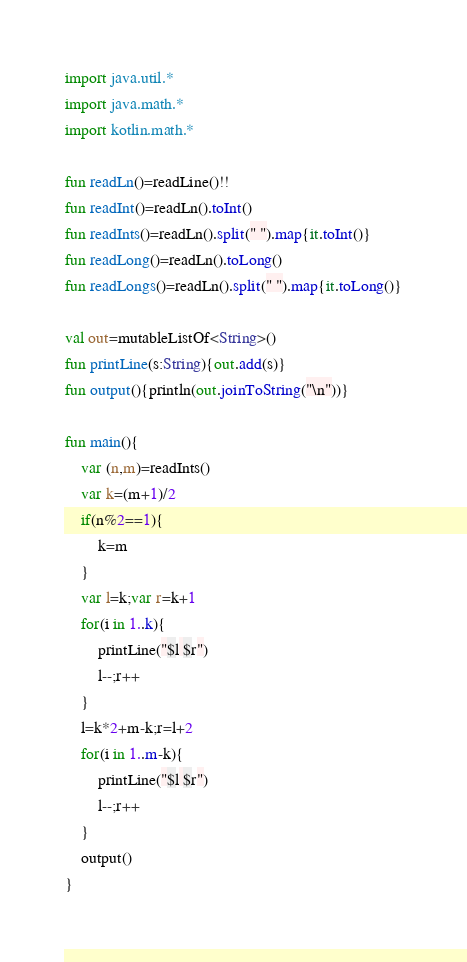Convert code to text. <code><loc_0><loc_0><loc_500><loc_500><_Kotlin_>import java.util.*
import java.math.*
import kotlin.math.*

fun readLn()=readLine()!!
fun readInt()=readLn().toInt()
fun readInts()=readLn().split(" ").map{it.toInt()}
fun readLong()=readLn().toLong()
fun readLongs()=readLn().split(" ").map{it.toLong()}

val out=mutableListOf<String>()
fun printLine(s:String){out.add(s)}
fun output(){println(out.joinToString("\n"))}

fun main(){
    var (n,m)=readInts()
    var k=(m+1)/2
    if(n%2==1){
        k=m
    }
    var l=k;var r=k+1
    for(i in 1..k){
        printLine("$l $r")
        l--;r++
    }
    l=k*2+m-k;r=l+2
    for(i in 1..m-k){
        printLine("$l $r")
        l--;r++
    }
    output()
}</code> 